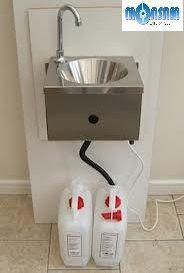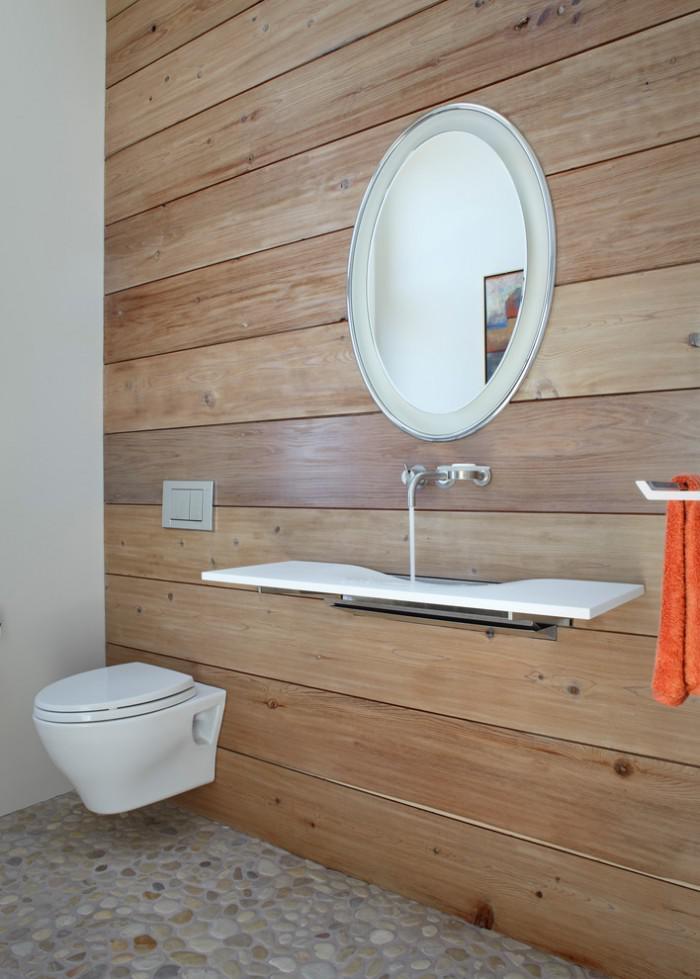The first image is the image on the left, the second image is the image on the right. Considering the images on both sides, is "A sink cabinet stands flush against a wall and has two full-length front panel doors that open at the center, with black handles at upper center," valid? Answer yes or no. No. The first image is the image on the left, the second image is the image on the right. Given the left and right images, does the statement "A sink unit has a rectangular double-door cabinet underneath at least one rectangular inset sink." hold true? Answer yes or no. No. 